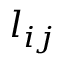<formula> <loc_0><loc_0><loc_500><loc_500>l _ { i j }</formula> 